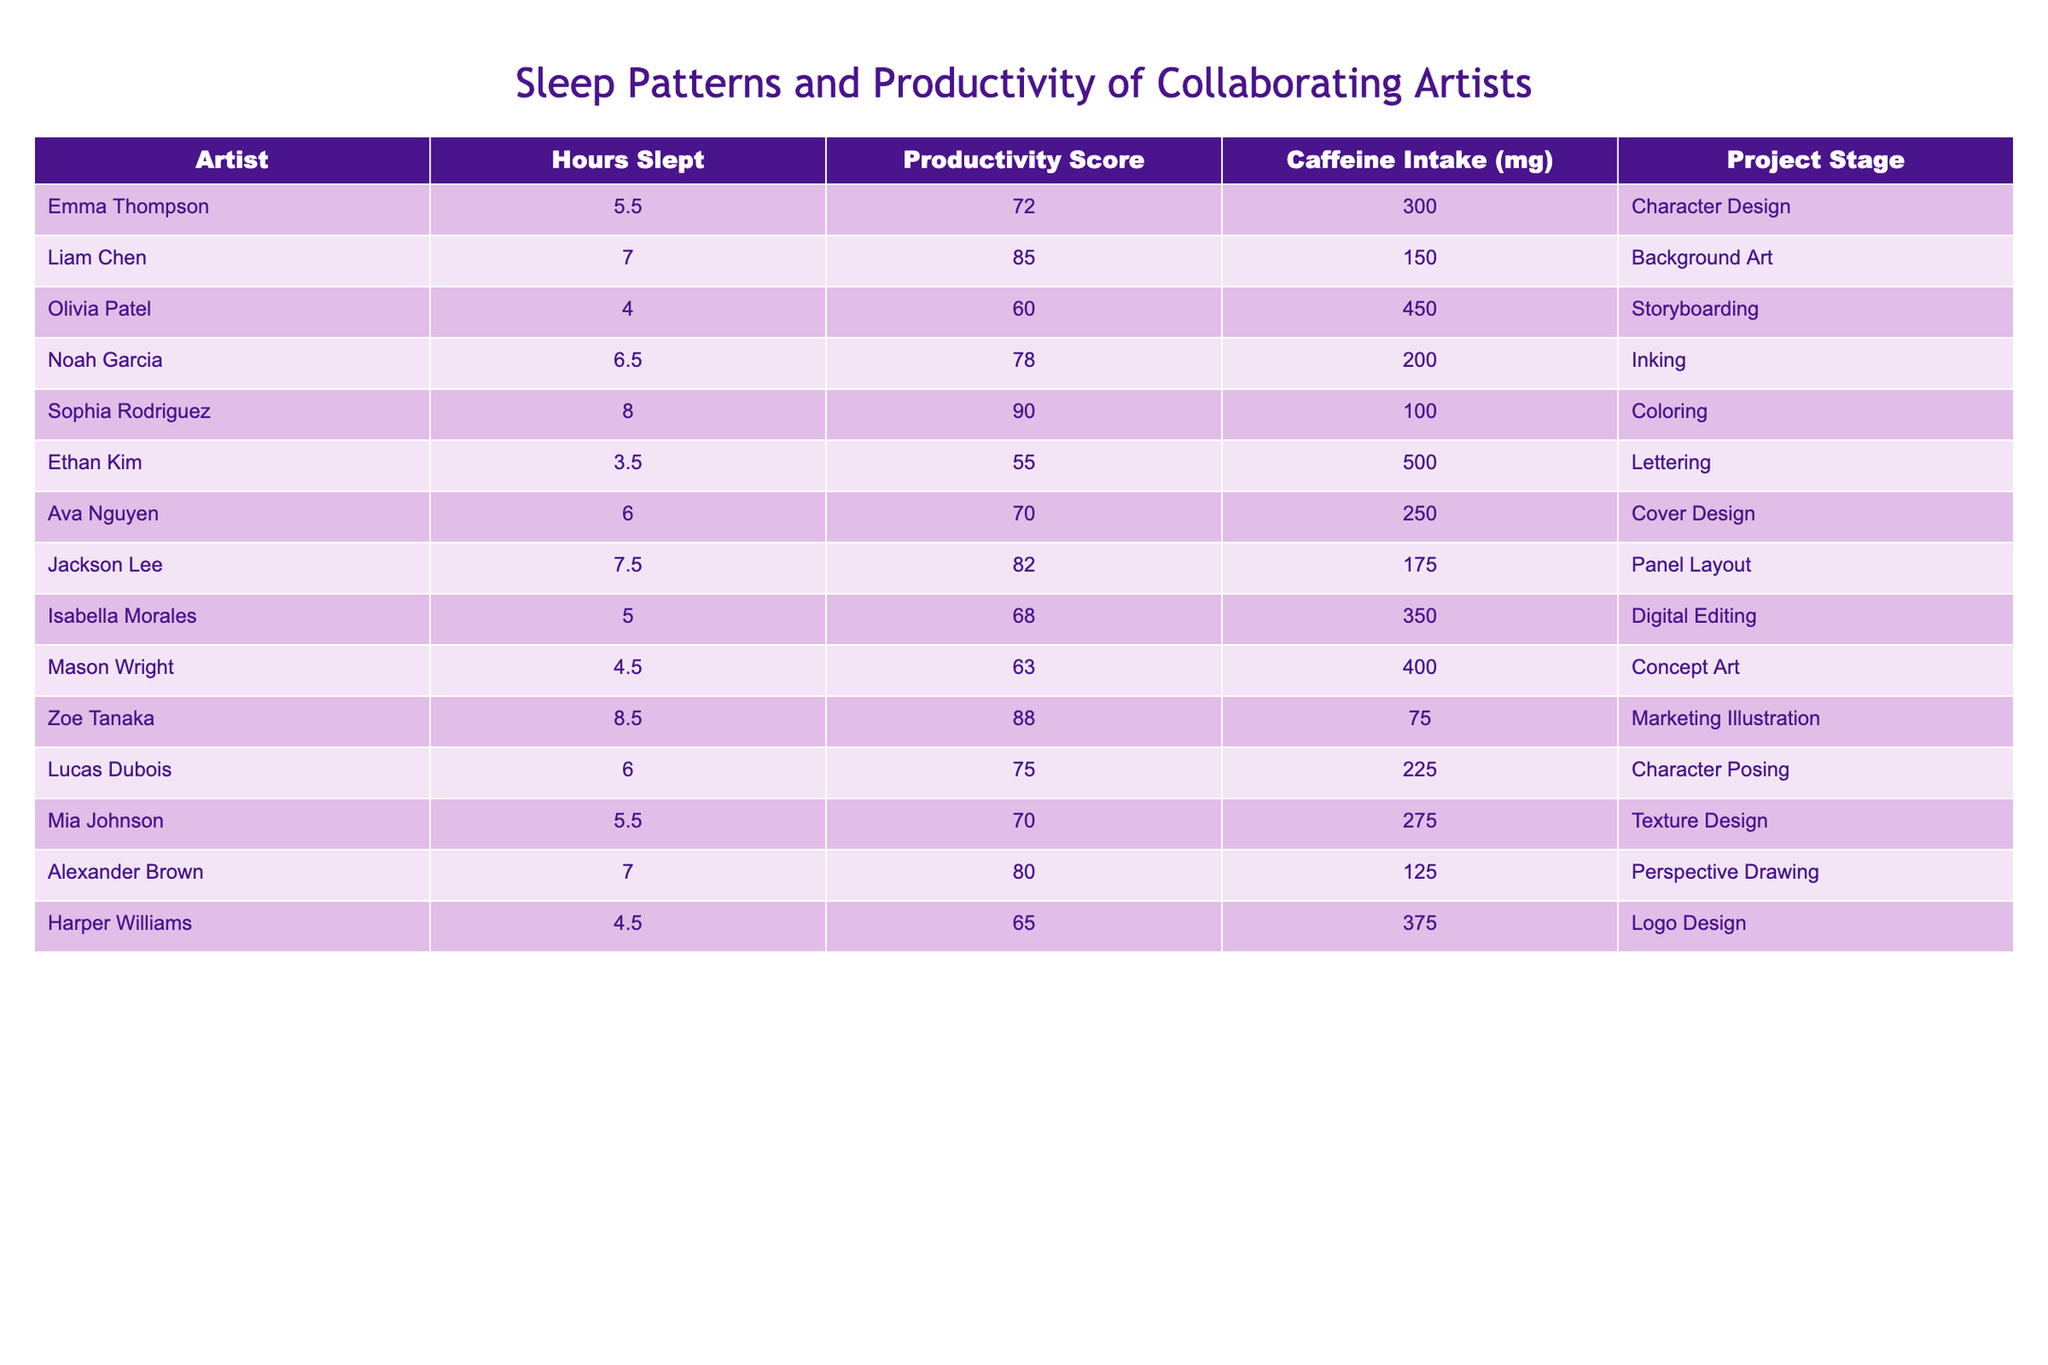What is the productivity score of Emma Thompson? By looking at the row for Emma Thompson in the table, her productivity score is directly listed as 72.
Answer: 72 Who among the artists slept the most hours? By comparing the 'Hours Slept' column, Zoe Tanaka has the highest value at 8.5 hours.
Answer: 8.5 What is the average caffeine intake of all the artists? Adding all the caffeine intakes: (300 + 150 + 450 + 200 + 100 + 500 + 250 + 175 + 350 + 400 + 225 + 75 + 275 + 125 + 375) = 3675. There are 15 artists, so the average is 3675 / 15 = 245 mg.
Answer: 245 mg Is there a correlation between hours slept and productivity score for all artists? By checking the highest productivity scores, the artists who slept more (like Sophia Rodriguez) tend to have higher productivity scores compared to those who slept less (like Ethan Kim); thus, a correlation can be inferred but not definitively established with this data alone.
Answer: Yes What is the total productivity score of artists who slept less than six hours? Listing those artists: Ethan Kim (55) + Olivia Patel (60) + Mason Wright (63) + Harper Williams (65) = 243.
Answer: 243 Who has the lowest productivity score and how many hours did they sleep? Looking for the lowest productivity score in the 'Productivity Score' column, Ethan Kim has 55 and he slept for 3.5 hours.
Answer: 55, 3.5 What is the difference in productivity scores between the artist who slept the least and the one who slept the most? From the data, Ethan Kim has the lowest score of 55 and Zoe Tanaka has the highest score of 88. The difference is 88 - 55 = 33.
Answer: 33 How many artists consumed more than 300 mg of caffeine? Checking the 'Caffeine Intake (mg)' column, the artists with more than 300 mg are Emma Thompson, Olivia Patel, Ethan Kim, Isabella Morales, and Mason Wright. That totals to 5 artists.
Answer: 5 Which artist is in the 'Coloring' project stage and what are their productivity and caffeine intake levels? From the 'Project Stage' column, Sophia Rodriguez is in 'Coloring', with a productivity score of 90 and caffeine intake of 100 mg.
Answer: Sophia Rodriguez, 90, 100 mg What is the median hours slept among all artists? To find the median, first arrange the hours slept: 3.5, 4, 4.5, 5, 5.5, 6, 6, 6.5, 7, 7, 7.5, 8, 8.5. The median of the 15 values (middle value) is the 8th point: 6.
Answer: 6 What percentage of artists had a productivity score above 80? Artists above a score of 80 are: Liam Chen (85), Sophia Rodriguez (90), Jackson Lee (82), and Zoe Tanaka (88) – that’s 4 out of 15 artists. Therefore, (4 / 15) * 100 = 26.67%.
Answer: 26.67% How does caffeine consumption impact the productivity scores of artists? While a detailed analysis is needed, generally looking at the data, high caffeine intake does not consistently correlate with high productivity scores as seen with Ethan Kim. It suggests other factors are at play.
Answer: Not consistent Which project stage has the highest average productivity score? Analyzing the project stages, 'Character Design' has an average productivity of (72) only one entry; 'Background Art' has (85); 'Coloring' has (90); 'Digital Editing' has (68) among others, thus 'Coloring' leads.
Answer: Coloring 